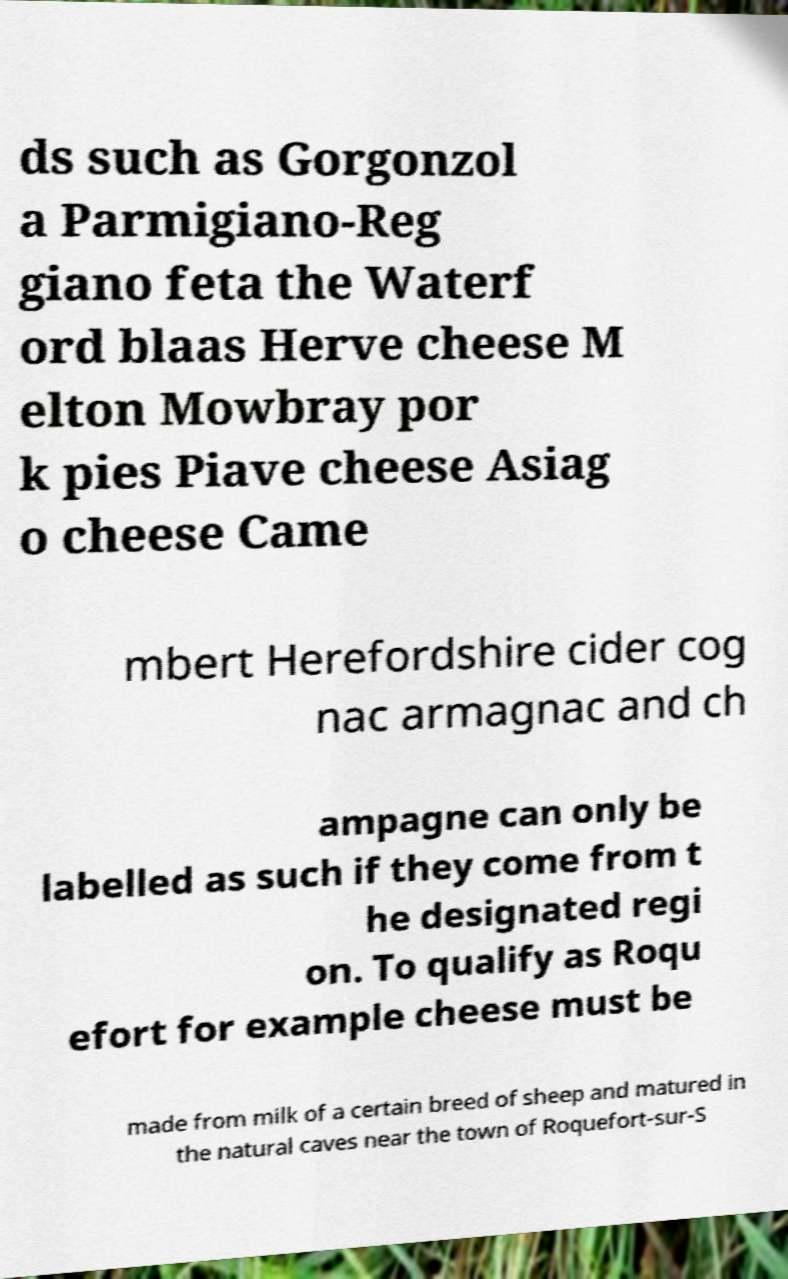I need the written content from this picture converted into text. Can you do that? ds such as Gorgonzol a Parmigiano-Reg giano feta the Waterf ord blaas Herve cheese M elton Mowbray por k pies Piave cheese Asiag o cheese Came mbert Herefordshire cider cog nac armagnac and ch ampagne can only be labelled as such if they come from t he designated regi on. To qualify as Roqu efort for example cheese must be made from milk of a certain breed of sheep and matured in the natural caves near the town of Roquefort-sur-S 